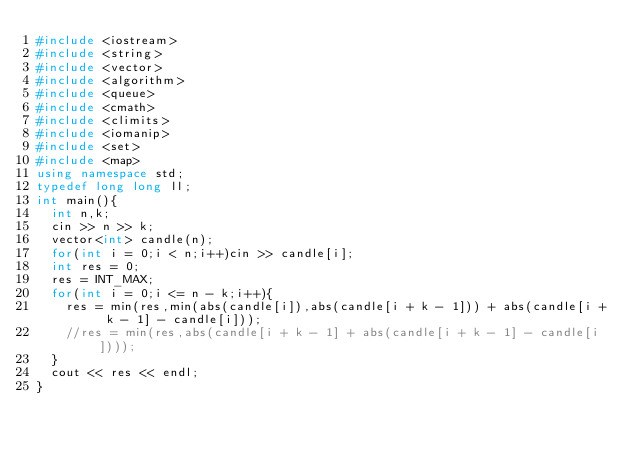Convert code to text. <code><loc_0><loc_0><loc_500><loc_500><_C++_>#include <iostream>
#include <string>
#include <vector>
#include <algorithm>
#include <queue>
#include <cmath>
#include <climits>
#include <iomanip>
#include <set>
#include <map>
using namespace std;
typedef long long ll;
int main(){
  int n,k;
  cin >> n >> k;
  vector<int> candle(n);
  for(int i = 0;i < n;i++)cin >> candle[i];
  int res = 0;
  res = INT_MAX;
  for(int i = 0;i <= n - k;i++){
    res = min(res,min(abs(candle[i]),abs(candle[i + k - 1])) + abs(candle[i + k - 1] - candle[i]));
    //res = min(res,abs(candle[i + k - 1] + abs(candle[i + k - 1] - candle[i])));
  }
  cout << res << endl;
}</code> 